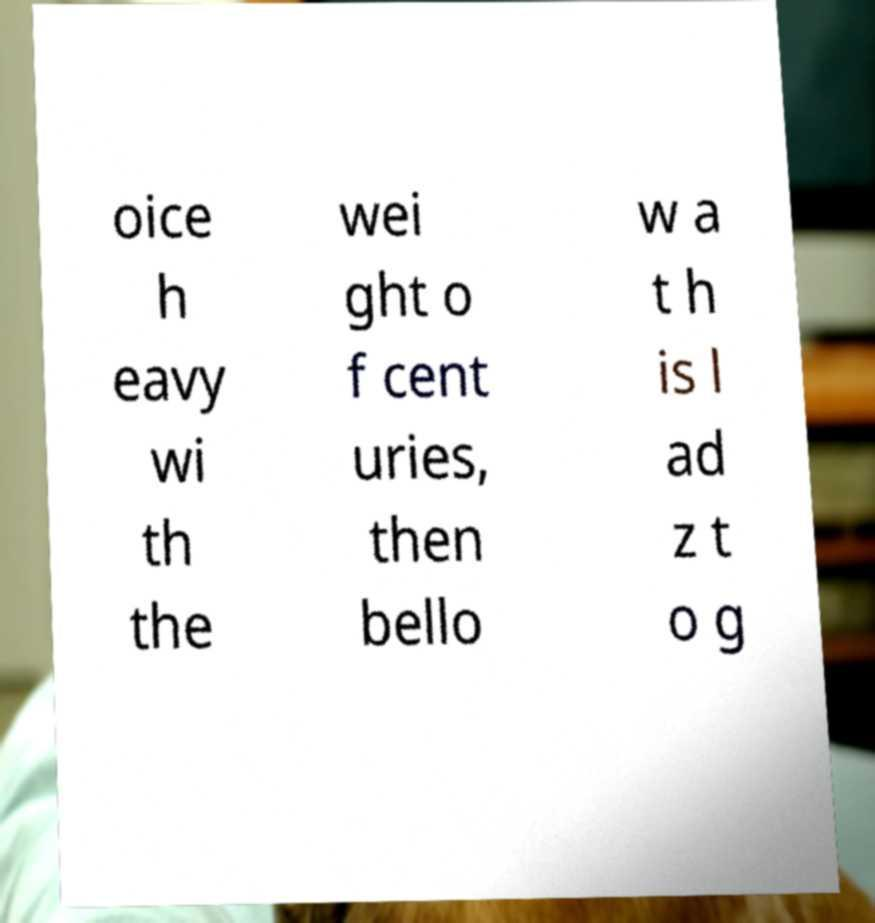For documentation purposes, I need the text within this image transcribed. Could you provide that? oice h eavy wi th the wei ght o f cent uries, then bello w a t h is l ad z t o g 